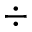Convert formula to latex. <formula><loc_0><loc_0><loc_500><loc_500>\div</formula> 